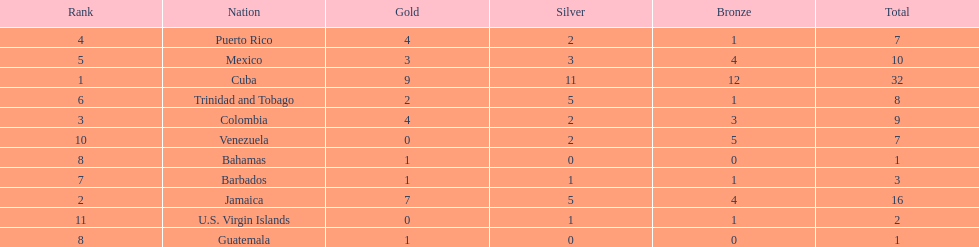Nations that had 10 or more medals each Cuba, Jamaica, Mexico. 